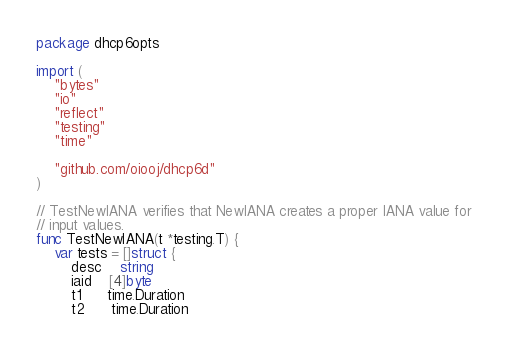Convert code to text. <code><loc_0><loc_0><loc_500><loc_500><_Go_>package dhcp6opts

import (
	"bytes"
	"io"
	"reflect"
	"testing"
	"time"

	"github.com/oiooj/dhcp6d"
)

// TestNewIANA verifies that NewIANA creates a proper IANA value for
// input values.
func TestNewIANA(t *testing.T) {
	var tests = []struct {
		desc    string
		iaid    [4]byte
		t1      time.Duration
		t2      time.Duration</code> 